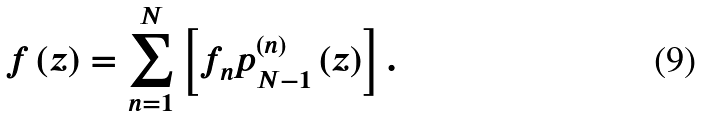<formula> <loc_0><loc_0><loc_500><loc_500>f \left ( z \right ) = \sum _ { n = 1 } ^ { N } \left [ f _ { n } p _ { N - 1 } ^ { \left ( n \right ) } \left ( z \right ) \right ] .</formula> 